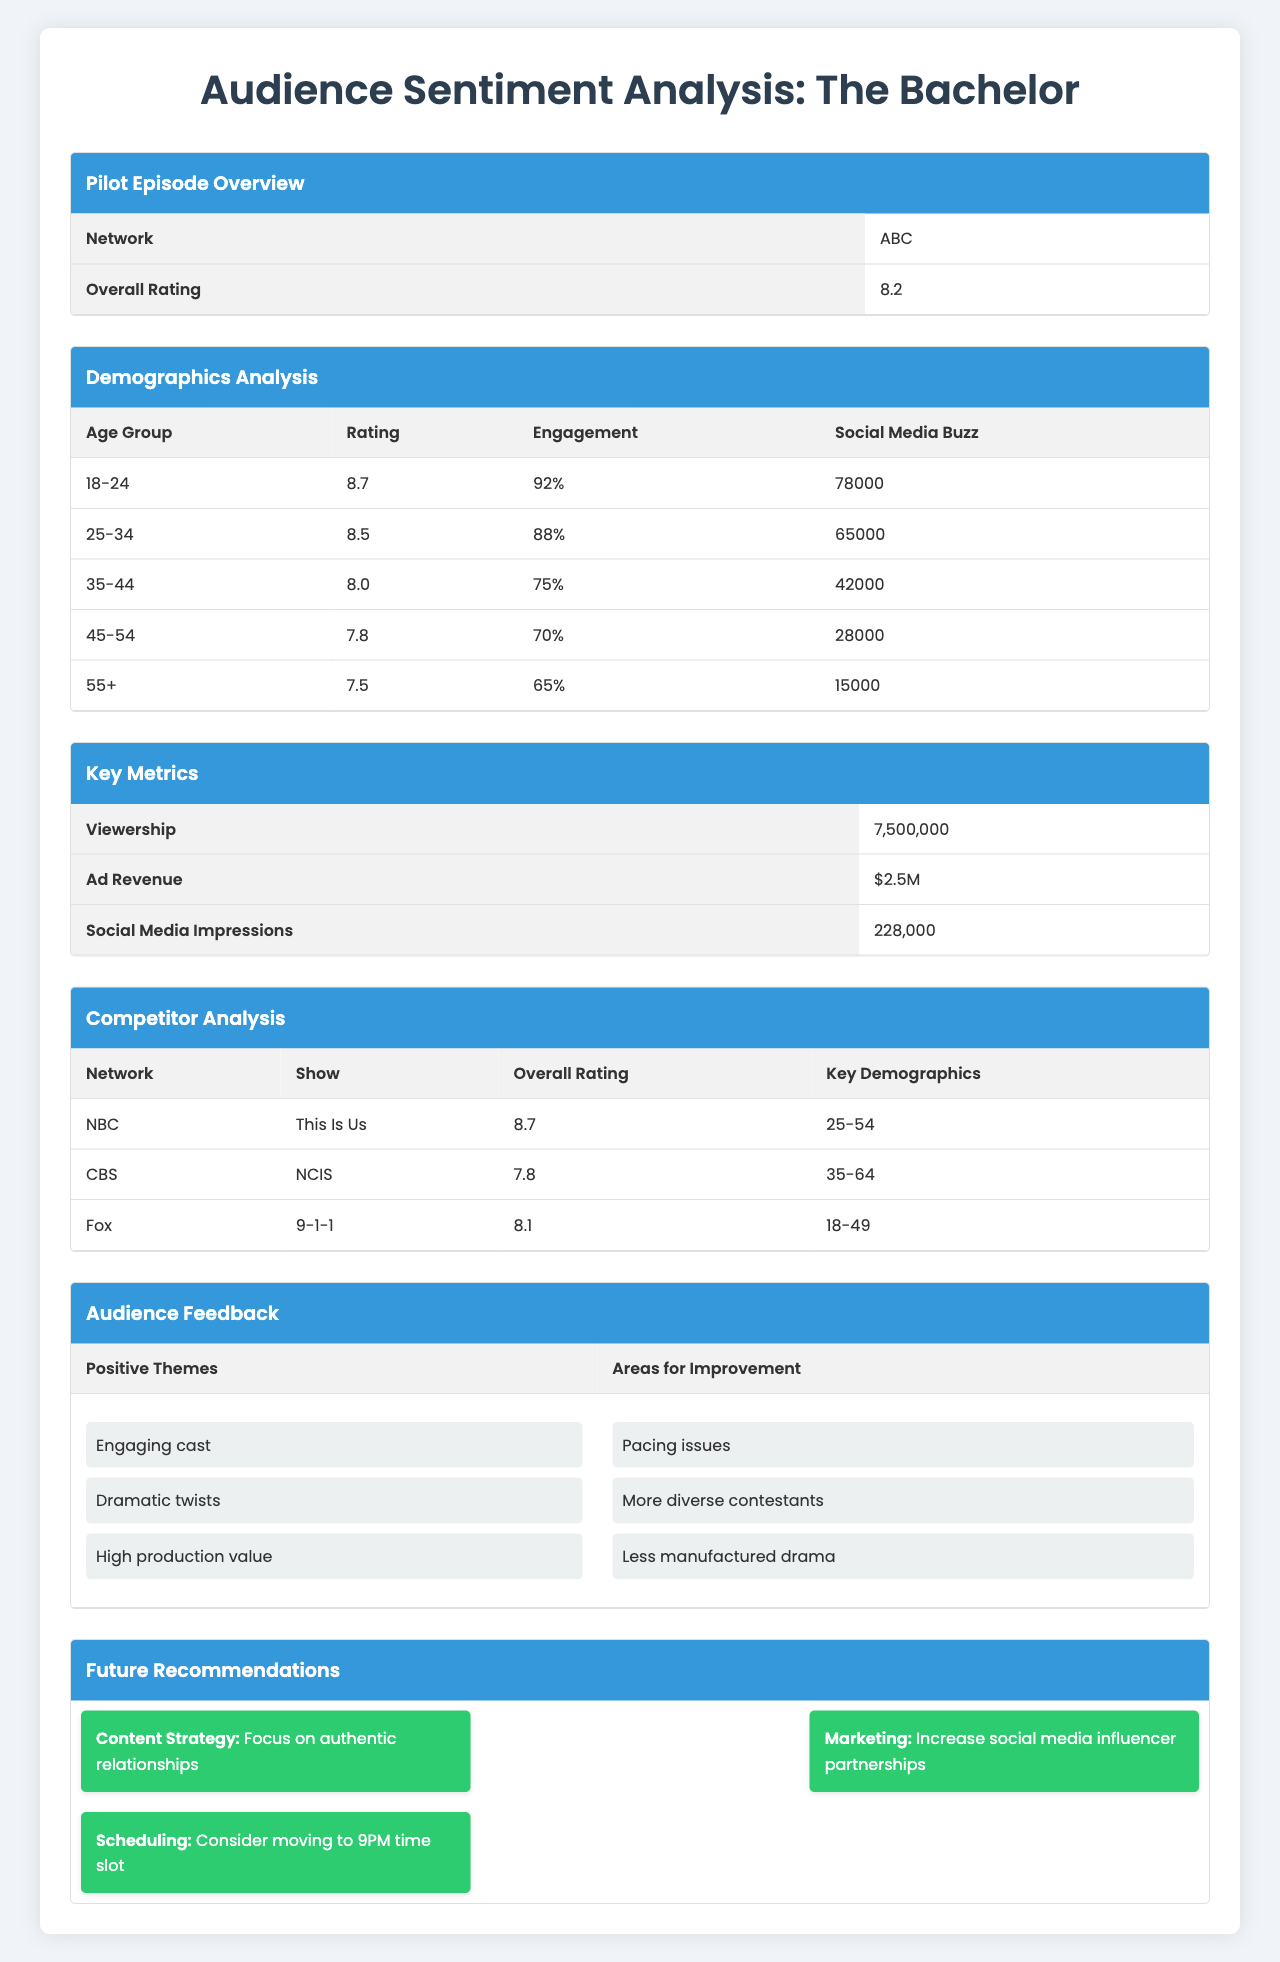What is the overall rating of "The Bachelor"? The table lists the overall rating for "The Bachelor" under the Pilot Episode Overview section, which shows it as 8.2.
Answer: 8.2 Which age group has the highest rating? In the Demographics Analysis section, the ratings for each age group are listed. The 18-24 age group has the highest rating of 8.7.
Answer: 18-24 What percentage engagement did the 45-54 age group show? The engagement percentage for the 45-54 age group is found in the Demographics Analysis section, which is listed as 70%.
Answer: 70% How many social media buzz mentions did the 25-34 age group generate? According to the Demographics Analysis section, the number of social media buzz mentions for the 25-34 age group is 65,000.
Answer: 65,000 What is the total social media buzz across all age groups? Summing up the social media buzz for all age groups gives: 78,000 + 65,000 + 42,000 + 28,000 + 15,000 = 228,000.
Answer: 228,000 Is the overall rating of "This Is Us" higher than that of "The Bachelor"? The overall rating of "This Is Us" is 8.7, and that of "The Bachelor" is 8.2. Since 8.7 is greater than 8.2, the statement is true.
Answer: Yes Which demographic group had the lowest engagement rate and what was it? The lowest engagement rate can be found in the Demographics Analysis section, where the 55+ demographic shows a rate of 65%.
Answer: 55+; 65% If the viewership of "The Bachelor" increased by 10%, what would that new number be? The original viewership is 7,500,000. An increase of 10% is calculated as 7,500,000 * 0.10 = 750,000. Adding this to the original gives 7,500,000 + 750,000 = 8,250,000.
Answer: 8,250,000 Which show has a lower overall rating, "NCIS" or "The Bachelor"? The overall rating for "NCIS" is 7.8, and for "The Bachelor," it is 8.2. Since 7.8 is less than 8.2, "NCIS" has the lower rating.
Answer: NCIS What recommendation is made about the content strategy? The recommendations section specifies that the content strategy should focus on authentic relationships, which is clearly stated in the table.
Answer: Focus on authentic relationships How many positive themes were identified in the audience feedback? The feedback section lists three positive themes, which are engaging cast, dramatic twists, and high production value. Therefore, the count is three.
Answer: 3 What is the average rating of the demographics between the age groups 18-24 and 35-44? The ratings for 18-24 and 35-44 are 8.7 and 8.0, respectively. To find the average: (8.7 + 8.0)/2 = 8.35.
Answer: 8.35 